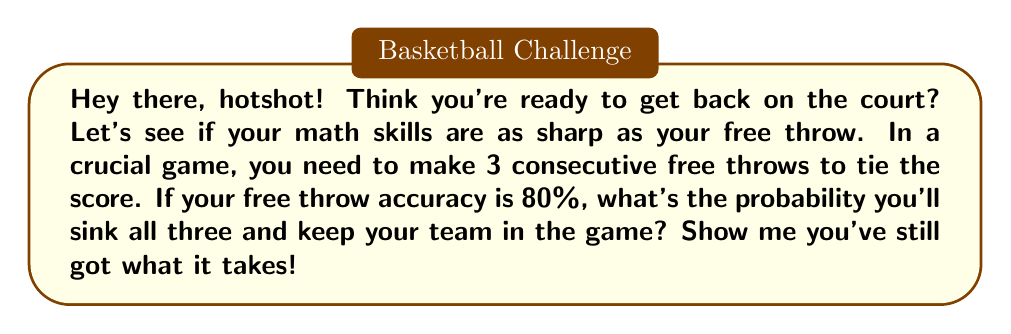Help me with this question. Let's break this down step-by-step:

1) First, we need to understand what "consecutive" means in probability. It means we need to calculate the probability of making the first AND the second AND the third free throw.

2) In probability, when we have independent events that all need to occur, we multiply the probabilities of each event.

3) The probability of making a single free throw is 80% or 0.8.

4) So, we need to calculate:

   $P(\text{making all 3}) = P(\text{1st}) \times P(\text{2nd}) \times P(\text{3rd})$

5) Substituting the values:

   $P(\text{making all 3}) = 0.8 \times 0.8 \times 0.8$

6) Calculating:

   $P(\text{making all 3}) = 0.8^3 = 0.512$

7) Converting to a percentage:

   $0.512 \times 100\% = 51.2\%$

Therefore, the probability of making all three consecutive free throws is 51.2%.
Answer: 51.2% 